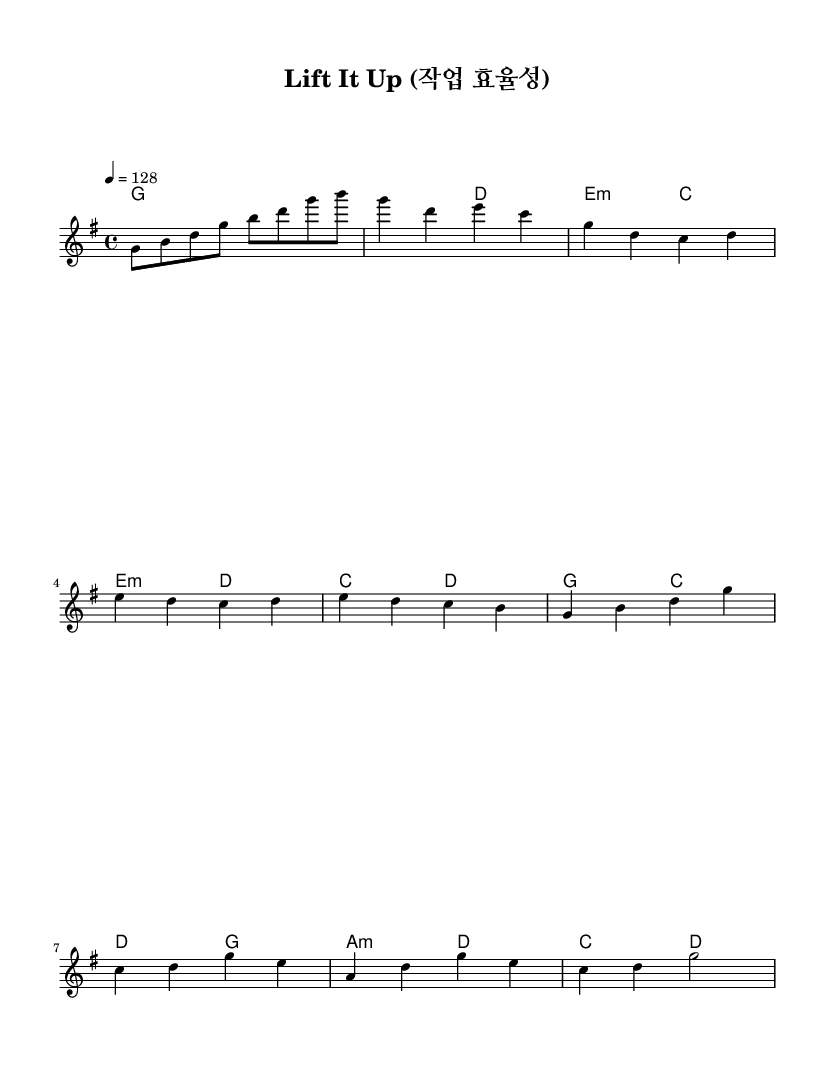What is the key signature of this music? The key signature is indicated by the sharps or flats at the beginning of the staff. In this sheet music, there are no sharps or flats, which corresponds to G major.
Answer: G major What is the time signature of this song? The time signature is shown as two numbers at the beginning of the staff. In this music, the numbers indicate that there are four beats in each measure, and the quarter note gets one beat. This is a "4/4" time signature.
Answer: 4/4 What is the tempo of the piece? The tempo marking is given in quarter note beats per minute at the beginning of the score. Here, it is set to 128, indicating that there should be 128 quarter note beats in one minute.
Answer: 128 How many measures are there in the Chorus section? By counting the measures notated in the Chorus section of the score, we see there are four measures. Each measure is separated by vertical bar lines, making it easy to count them.
Answer: 4 What type of chord is used in the Pre-Chorus? In the Pre-Chorus section, there are "E minor" and "D major" chords. These can be identified by the chord symbols written above the staff. The symbol "E2:m" indicates that it's an E minor chord.
Answer: E minor What is the emotional theme of this K-Pop song based on the title "Lift It Up"? The title suggests a motivational theme focusing on improving productivity and efficiency, which is a common theme in upbeat K-Pop songs, encouraging positivity in the workplace.
Answer: Motivational How does the use of rhythm contribute to the productivity theme? The upbeat tempo of 128 and the consistent 4/4 time signature create a driving, energetic rhythm, making the music lively and engaging, which aligns with the theme of productivity in the workplace.
Answer: Energetic 